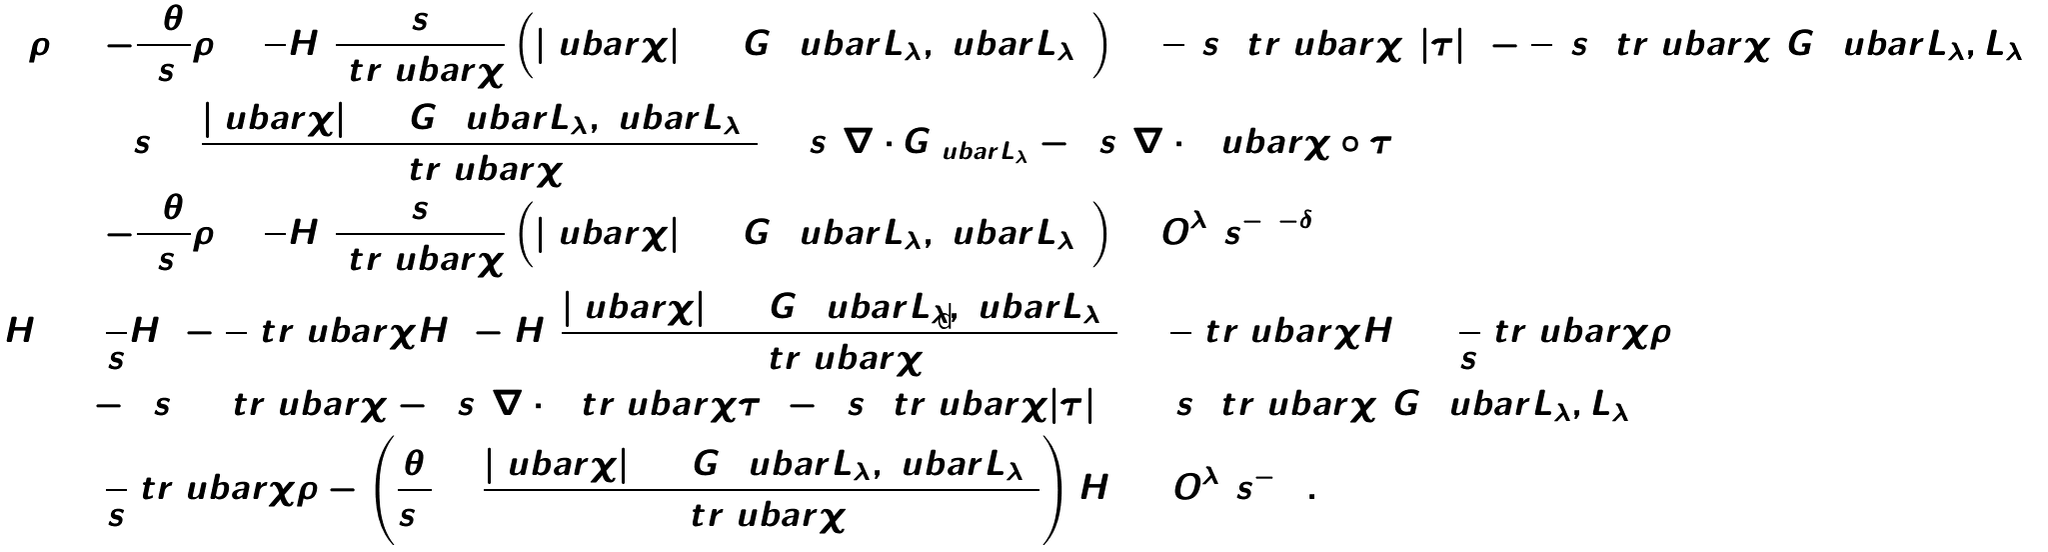Convert formula to latex. <formula><loc_0><loc_0><loc_500><loc_500>\dot { \tilde { \rho } } & = - \frac { 3 \theta } { 2 s ^ { 2 } } \tilde { \rho } + \frac { 1 } { 4 } \tilde { H } ^ { 2 } \frac { s } { \ t r \ u b a r \chi } \left ( | \hat { \ u b a r \chi } | ^ { 2 } + G ( \ u b a r L _ { \lambda } , \ u b a r L _ { \lambda } ) \right ) + \frac { 1 } { 2 } ( s ^ { 3 } \ t r \ u b a r \chi ) | \tau | ^ { 2 } - \frac { 1 } { 4 } ( s ^ { 3 } \ t r \ u b a r \chi ) G ( \ u b a r L _ { \lambda } , L _ { \lambda } ) \\ & \quad + s ^ { 3 } \Delta \frac { | \hat { \ u b a r \chi } | ^ { 2 } + G ( \ u b a r L _ { \lambda } , \ u b a r L _ { \lambda } ) } { \ t r \ u b a r \chi } + s ^ { 3 } \nabla \cdot G _ { \ u b a r L _ { \lambda } } - 2 s ^ { 3 } \nabla \cdot ( { \hat { \ u b a r \chi } } \circ \tau ) \\ & = - \frac { 3 \theta } { 2 s ^ { 2 } } \tilde { \rho } + \frac { 1 } { 4 } \tilde { H } ^ { 2 } \frac { s } { \ t r \ u b a r \chi } \left ( | \hat { \ u b a r \chi } | ^ { 2 } + G ( \ u b a r L _ { \lambda } , \ u b a r L _ { \lambda } ) \right ) + O ^ { \lambda } _ { 2 } ( s ^ { - 1 - \delta } ) \\ \dot { \tilde { H } } ^ { 2 } & = \frac { 2 } { s } \tilde { H } ^ { 2 } - \frac { 3 } { 2 } \ t r \ u b a r \chi \tilde { H } ^ { 2 } - \tilde { H } ^ { 2 } \frac { | \hat { \ u b a r \chi } | ^ { 2 } + G ( \ u b a r L _ { \lambda } , \ u b a r L _ { \lambda } ) } { \ t r \ u b a r \chi } + \frac { 1 } { 2 } \ t r \ u b a r \chi \tilde { H } ^ { 2 } + \frac { 2 } { s } \ t r \ u b a r \chi \tilde { \rho } \\ & \quad - 2 s ^ { 2 } \Delta \ t r \ u b a r \chi - 4 s ^ { 2 } \nabla \cdot ( \ t r \ u b a r \chi \tau ) - 2 s ^ { 2 } \ t r \ u b a r \chi | \tau | ^ { 2 } + ( s ^ { 2 } \ t r \ u b a r \chi ) G ( \ u b a r L _ { \lambda } , L _ { \lambda } ) \\ & = \frac { 2 } { s } \ t r \ u b a r \chi \tilde { \rho } - \left ( \frac { \theta } { s ^ { 2 } } + \frac { | \hat { \ u b a r \chi } | ^ { 2 } + G ( \ u b a r L _ { \lambda } , \ u b a r L _ { \lambda } ) } { \ t r \ u b a r \chi } \right ) \tilde { H } ^ { 2 } + O ^ { \lambda } _ { 2 } ( s ^ { - 2 } ) .</formula> 